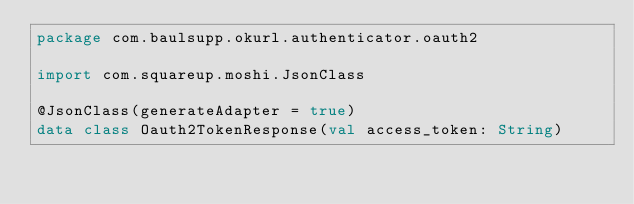Convert code to text. <code><loc_0><loc_0><loc_500><loc_500><_Kotlin_>package com.baulsupp.okurl.authenticator.oauth2

import com.squareup.moshi.JsonClass

@JsonClass(generateAdapter = true)
data class Oauth2TokenResponse(val access_token: String)
</code> 